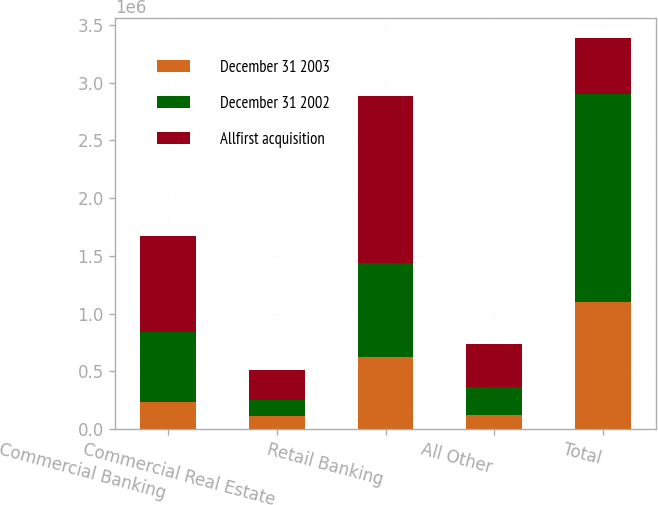Convert chart. <chart><loc_0><loc_0><loc_500><loc_500><stacked_bar_chart><ecel><fcel>Commercial Banking<fcel>Commercial Real Estate<fcel>Retail Banking<fcel>All Other<fcel>Total<nl><fcel>December 31 2003<fcel>236012<fcel>114883<fcel>627564<fcel>119094<fcel>1.09755e+06<nl><fcel>December 31 2002<fcel>602153<fcel>140283<fcel>813361<fcel>250731<fcel>1.80653e+06<nl><fcel>Allfirst acquisition<fcel>838165<fcel>255166<fcel>1.44092e+06<fcel>369825<fcel>485989<nl></chart> 